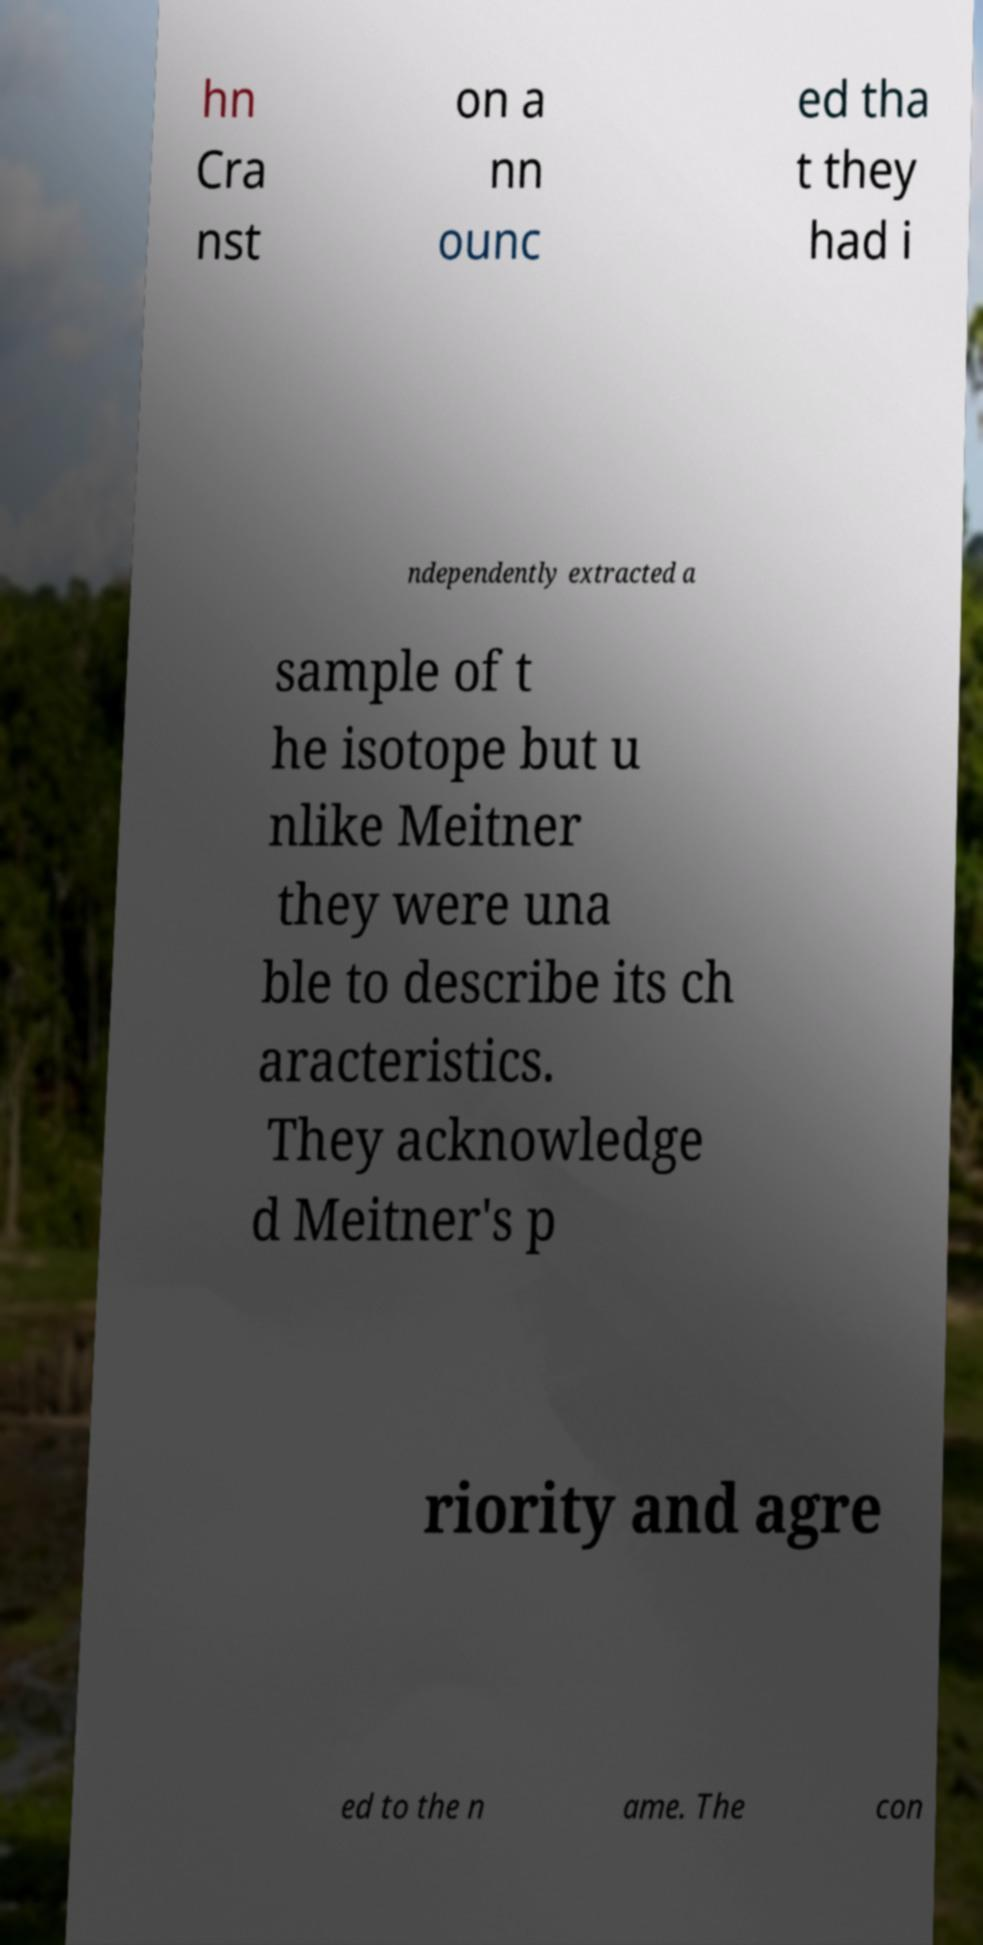Could you assist in decoding the text presented in this image and type it out clearly? hn Cra nst on a nn ounc ed tha t they had i ndependently extracted a sample of t he isotope but u nlike Meitner they were una ble to describe its ch aracteristics. They acknowledge d Meitner's p riority and agre ed to the n ame. The con 